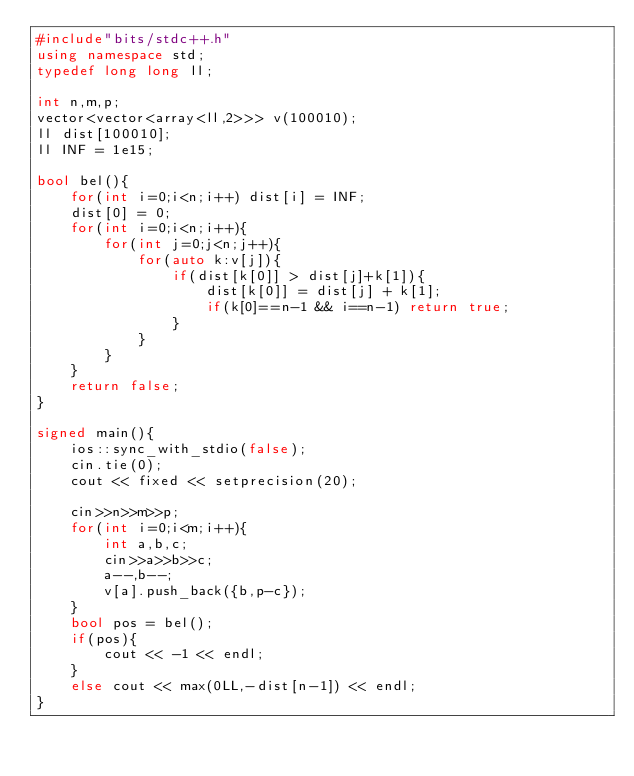<code> <loc_0><loc_0><loc_500><loc_500><_C++_>#include"bits/stdc++.h"
using namespace std;
typedef long long ll;

int n,m,p;
vector<vector<array<ll,2>>> v(100010);
ll dist[100010];
ll INF = 1e15;

bool bel(){
    for(int i=0;i<n;i++) dist[i] = INF;
    dist[0] = 0;
    for(int i=0;i<n;i++){
        for(int j=0;j<n;j++){
            for(auto k:v[j]){
                if(dist[k[0]] > dist[j]+k[1]){
                    dist[k[0]] = dist[j] + k[1];
                    if(k[0]==n-1 && i==n-1) return true;
                }
            }
        }
    }
    return false;
}

signed main(){
    ios::sync_with_stdio(false);
    cin.tie(0);
    cout << fixed << setprecision(20);

    cin>>n>>m>>p;
    for(int i=0;i<m;i++){
        int a,b,c;
        cin>>a>>b>>c;
        a--,b--;
        v[a].push_back({b,p-c});
    }
    bool pos = bel();
    if(pos){
        cout << -1 << endl;
    }
    else cout << max(0LL,-dist[n-1]) << endl;
}</code> 